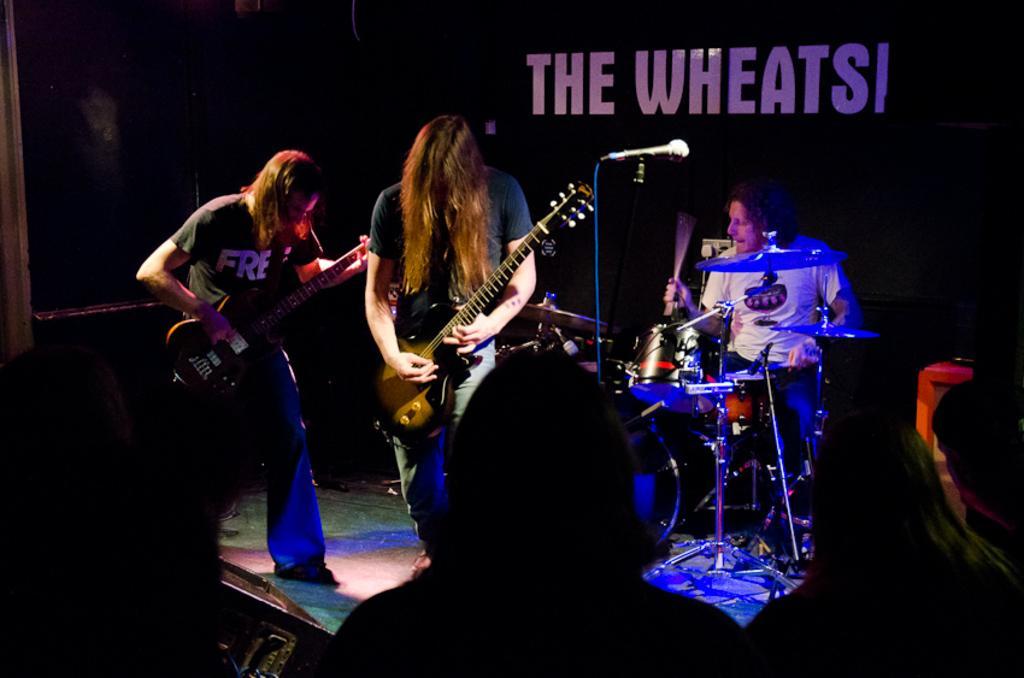Describe this image in one or two sentences. In the middle of the image few people are playing some musical instruments, Behind them there is a banner. 